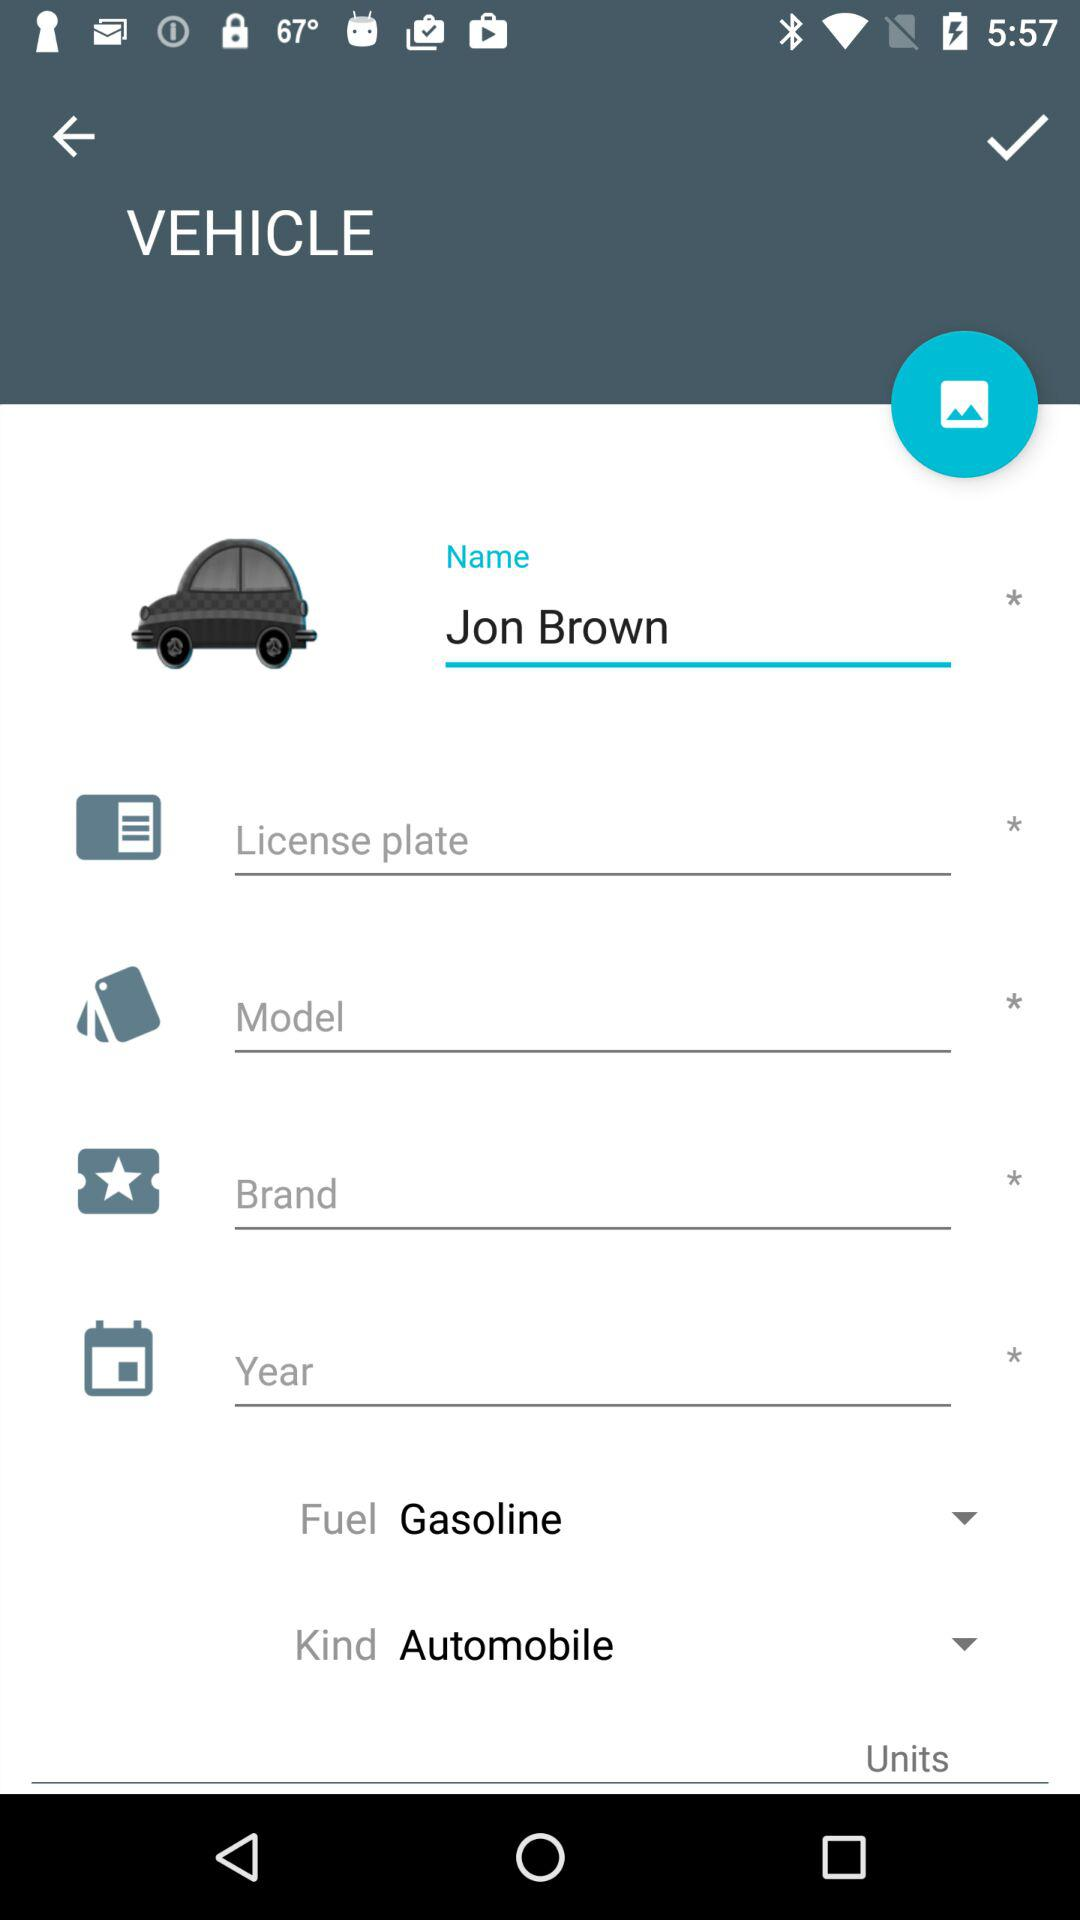What's the name? The name is Jon Brown. 